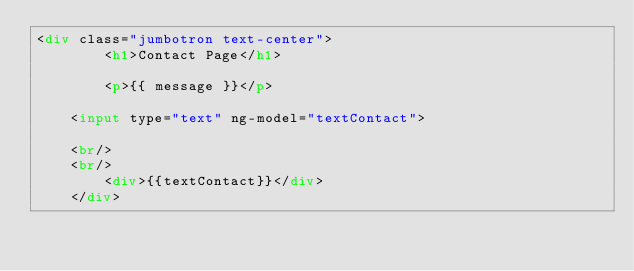Convert code to text. <code><loc_0><loc_0><loc_500><loc_500><_HTML_><div class="jumbotron text-center">
        <h1>Contact Page</h1>

        <p>{{ message }}</p>

		<input type="text" ng-model="textContact">

		<br/>
		<br/>
        <div>{{textContact}}</div>
    </div></code> 